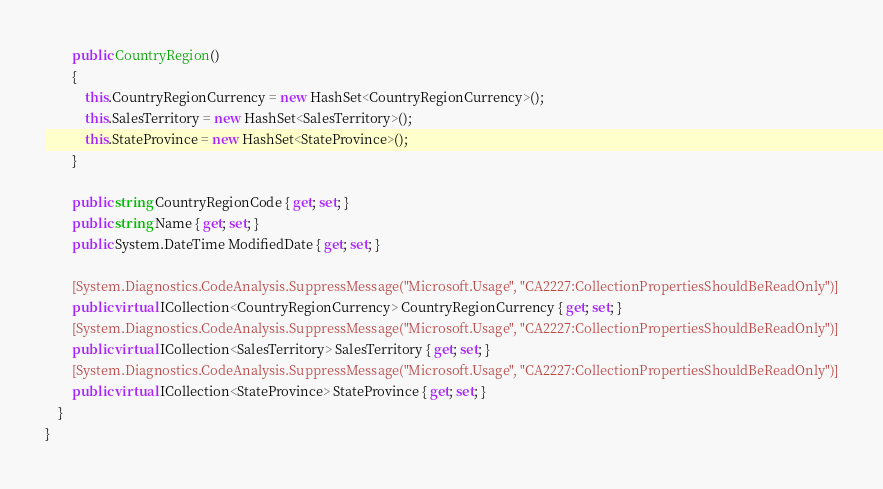<code> <loc_0><loc_0><loc_500><loc_500><_C#_>        public CountryRegion()
        {
            this.CountryRegionCurrency = new HashSet<CountryRegionCurrency>();
            this.SalesTerritory = new HashSet<SalesTerritory>();
            this.StateProvince = new HashSet<StateProvince>();
        }
    
        public string CountryRegionCode { get; set; }
        public string Name { get; set; }
        public System.DateTime ModifiedDate { get; set; }
    
        [System.Diagnostics.CodeAnalysis.SuppressMessage("Microsoft.Usage", "CA2227:CollectionPropertiesShouldBeReadOnly")]
        public virtual ICollection<CountryRegionCurrency> CountryRegionCurrency { get; set; }
        [System.Diagnostics.CodeAnalysis.SuppressMessage("Microsoft.Usage", "CA2227:CollectionPropertiesShouldBeReadOnly")]
        public virtual ICollection<SalesTerritory> SalesTerritory { get; set; }
        [System.Diagnostics.CodeAnalysis.SuppressMessage("Microsoft.Usage", "CA2227:CollectionPropertiesShouldBeReadOnly")]
        public virtual ICollection<StateProvince> StateProvince { get; set; }
    }
}
</code> 